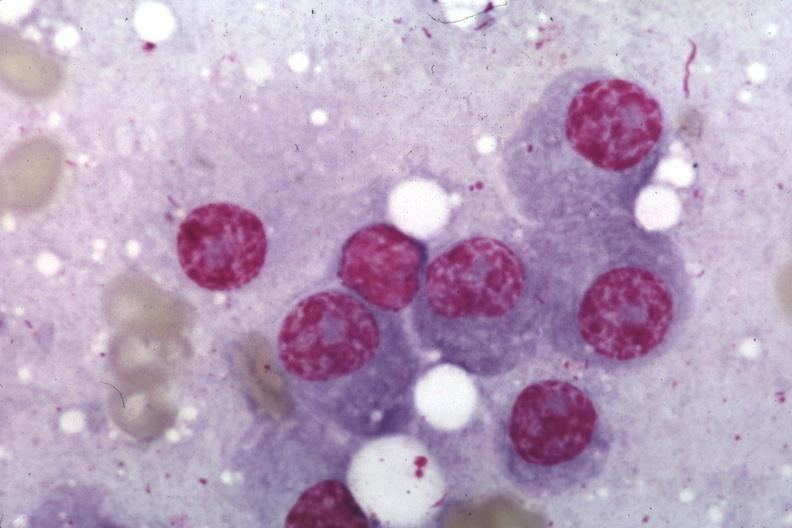does abdomen show wrights typical plasma cells?
Answer the question using a single word or phrase. No 